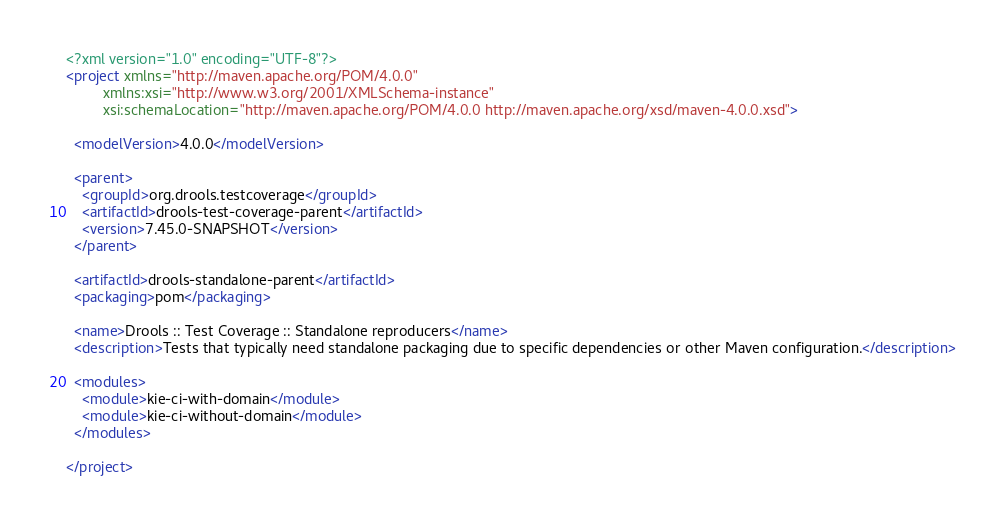Convert code to text. <code><loc_0><loc_0><loc_500><loc_500><_XML_><?xml version="1.0" encoding="UTF-8"?>
<project xmlns="http://maven.apache.org/POM/4.0.0"
         xmlns:xsi="http://www.w3.org/2001/XMLSchema-instance"
         xsi:schemaLocation="http://maven.apache.org/POM/4.0.0 http://maven.apache.org/xsd/maven-4.0.0.xsd">

  <modelVersion>4.0.0</modelVersion>

  <parent>
    <groupId>org.drools.testcoverage</groupId>
    <artifactId>drools-test-coverage-parent</artifactId>
    <version>7.45.0-SNAPSHOT</version>
  </parent>

  <artifactId>drools-standalone-parent</artifactId>
  <packaging>pom</packaging>

  <name>Drools :: Test Coverage :: Standalone reproducers</name>
  <description>Tests that typically need standalone packaging due to specific dependencies or other Maven configuration.</description>

  <modules>
    <module>kie-ci-with-domain</module>
    <module>kie-ci-without-domain</module>
  </modules>

</project>
</code> 